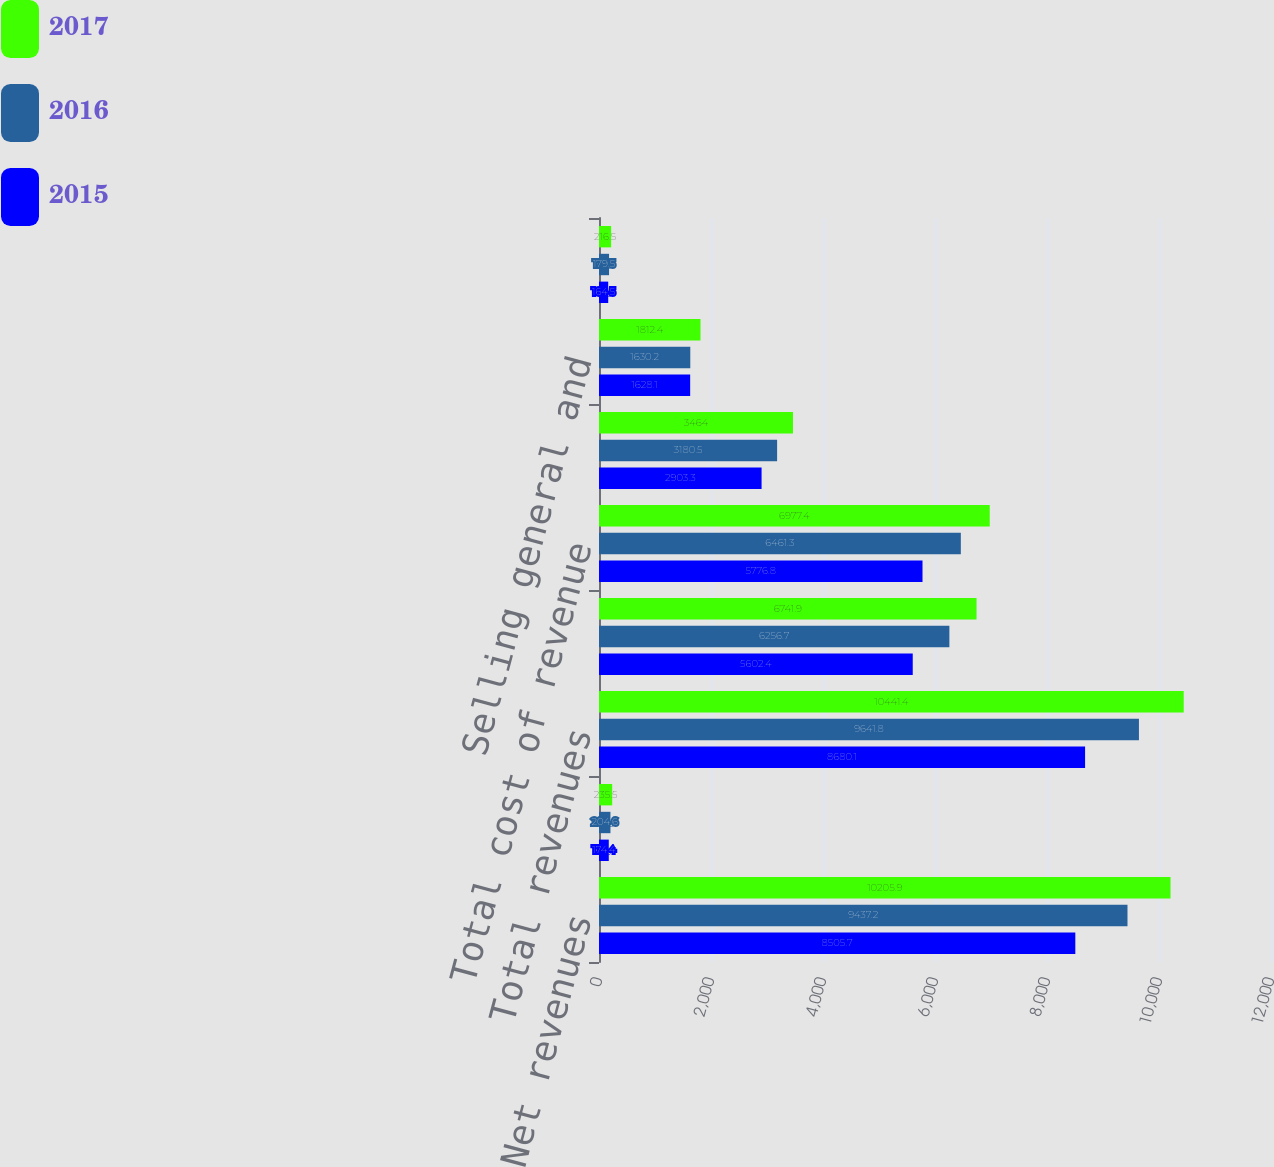Convert chart to OTSL. <chart><loc_0><loc_0><loc_500><loc_500><stacked_bar_chart><ecel><fcel>Net revenues<fcel>Reimbursable out-of-pocket<fcel>Total revenues<fcel>Net cost of revenue<fcel>Total cost of revenue<fcel>Gross profit<fcel>Selling general and<fcel>Amortization of intangibles<nl><fcel>2017<fcel>10205.9<fcel>235.5<fcel>10441.4<fcel>6741.9<fcel>6977.4<fcel>3464<fcel>1812.4<fcel>216.5<nl><fcel>2016<fcel>9437.2<fcel>204.6<fcel>9641.8<fcel>6256.7<fcel>6461.3<fcel>3180.5<fcel>1630.2<fcel>179.5<nl><fcel>2015<fcel>8505.7<fcel>174.4<fcel>8680.1<fcel>5602.4<fcel>5776.8<fcel>2903.3<fcel>1628.1<fcel>164.5<nl></chart> 